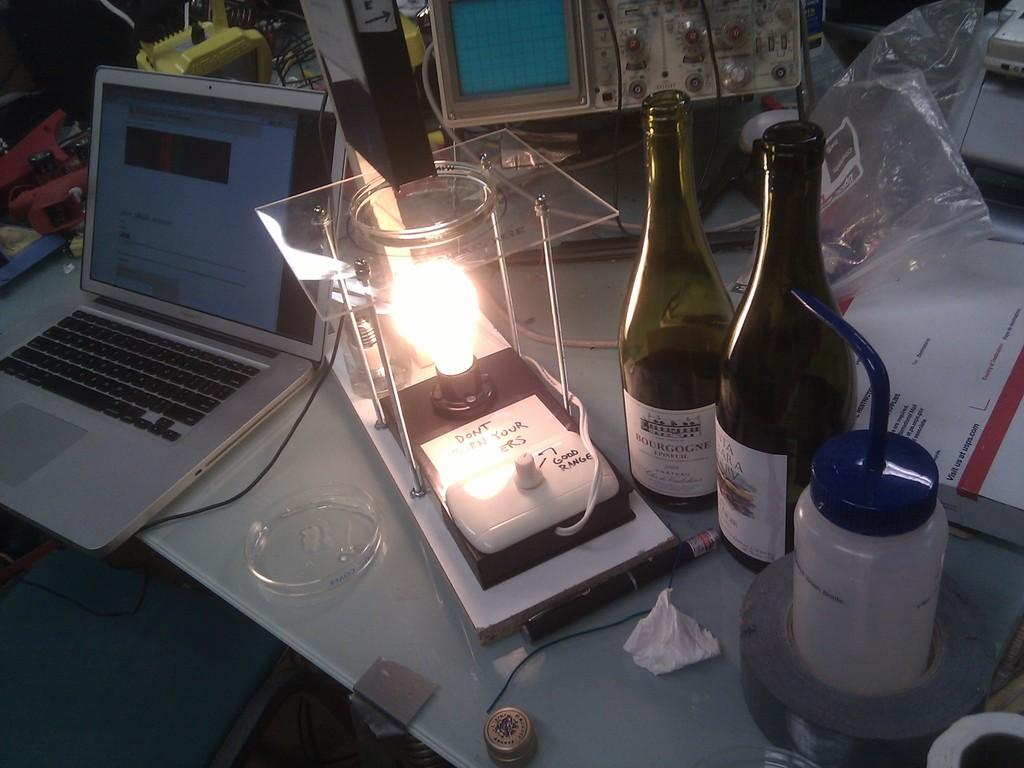What is the main piece of furniture in the image? There is a table in the image. What electronic device is on the table? There is a laptop on the table. What other objects can be seen on the table? There is a machine, a plastic cover, two bottles, a bowl, a pen, tape, a bulb, and a glass flask on the table. What type of peace symbol is depicted in the frame on the table? There is no frame or peace symbol present in the image. What kind of leaf is used as a decoration on the table? There is no leaf present in the image. 